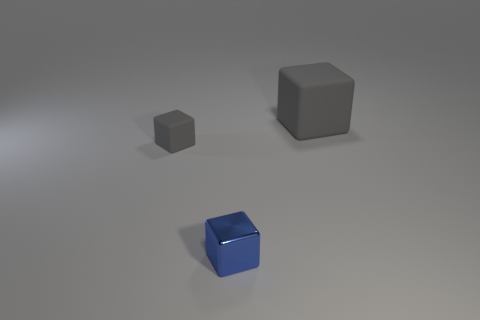Are there any blue shiny blocks that have the same size as the metallic object?
Provide a short and direct response. No. Are there the same number of tiny gray things that are in front of the blue thing and cyan spheres?
Your answer should be very brief. Yes. How many big matte things are in front of the big gray block right of the blue metal block?
Keep it short and to the point. 0. What shape is the object that is behind the tiny blue cube and to the right of the small matte block?
Keep it short and to the point. Cube. How many matte cubes are the same color as the big matte thing?
Provide a short and direct response. 1. Are there any gray rubber cubes left of the large gray thing that is behind the tiny object behind the metal block?
Offer a terse response. Yes. How big is the block that is both right of the tiny gray rubber thing and behind the small metal cube?
Your answer should be compact. Large. How many other small blue objects have the same material as the blue object?
Your answer should be very brief. 0. How many blocks are either big cyan objects or tiny things?
Your answer should be compact. 2. How big is the gray matte block behind the matte object that is to the left of the small shiny object that is on the left side of the large cube?
Make the answer very short. Large. 